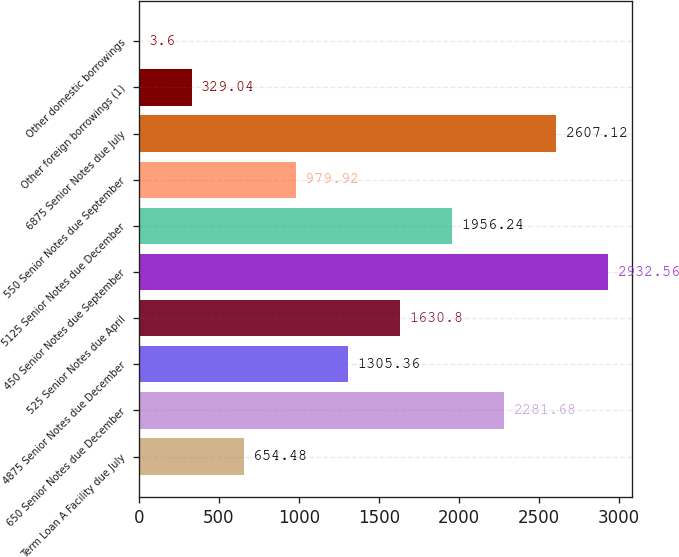<chart> <loc_0><loc_0><loc_500><loc_500><bar_chart><fcel>Term Loan A Facility due July<fcel>650 Senior Notes due December<fcel>4875 Senior Notes due December<fcel>525 Senior Notes due April<fcel>450 Senior Notes due September<fcel>5125 Senior Notes due December<fcel>550 Senior Notes due September<fcel>6875 Senior Notes due July<fcel>Other foreign borrowings (1)<fcel>Other domestic borrowings<nl><fcel>654.48<fcel>2281.68<fcel>1305.36<fcel>1630.8<fcel>2932.56<fcel>1956.24<fcel>979.92<fcel>2607.12<fcel>329.04<fcel>3.6<nl></chart> 